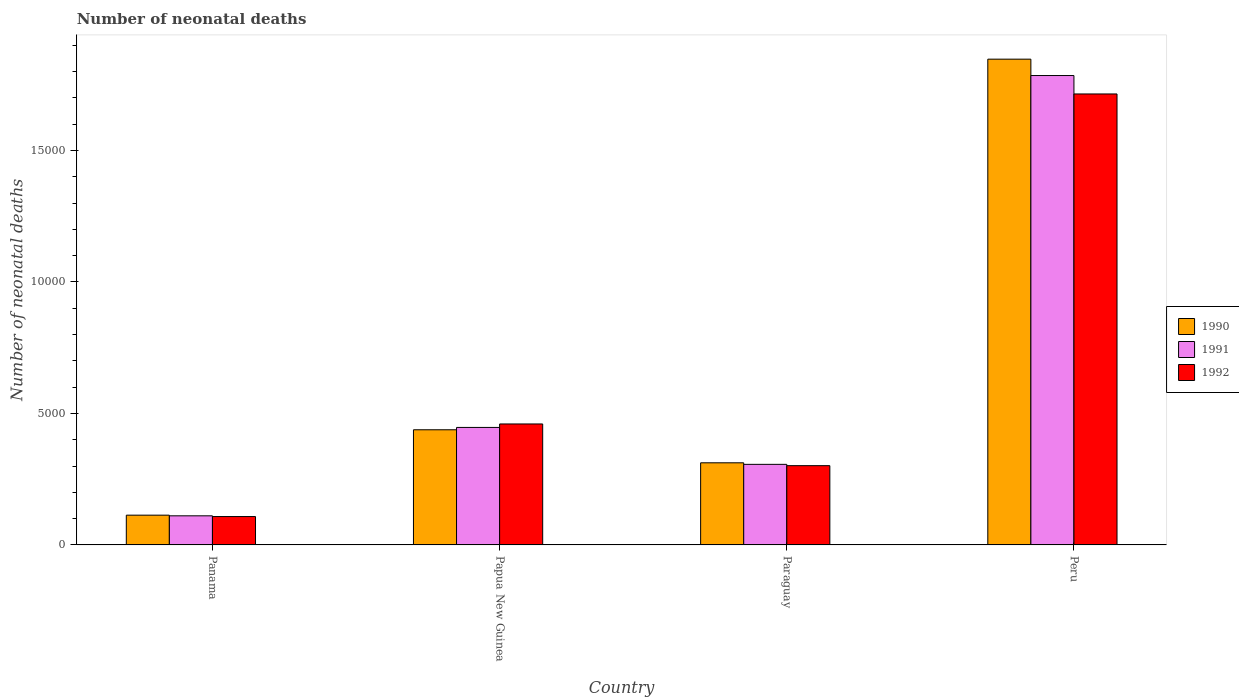How many groups of bars are there?
Keep it short and to the point. 4. Are the number of bars per tick equal to the number of legend labels?
Your answer should be very brief. Yes. How many bars are there on the 4th tick from the left?
Provide a succinct answer. 3. What is the label of the 4th group of bars from the left?
Your answer should be very brief. Peru. In how many cases, is the number of bars for a given country not equal to the number of legend labels?
Keep it short and to the point. 0. What is the number of neonatal deaths in in 1992 in Paraguay?
Ensure brevity in your answer.  3014. Across all countries, what is the maximum number of neonatal deaths in in 1990?
Ensure brevity in your answer.  1.85e+04. Across all countries, what is the minimum number of neonatal deaths in in 1992?
Your answer should be compact. 1079. In which country was the number of neonatal deaths in in 1991 minimum?
Offer a very short reply. Panama. What is the total number of neonatal deaths in in 1992 in the graph?
Provide a short and direct response. 2.58e+04. What is the difference between the number of neonatal deaths in in 1992 in Papua New Guinea and that in Peru?
Your response must be concise. -1.25e+04. What is the difference between the number of neonatal deaths in in 1992 in Papua New Guinea and the number of neonatal deaths in in 1991 in Panama?
Offer a terse response. 3493. What is the average number of neonatal deaths in in 1992 per country?
Offer a terse response. 6460.5. What is the difference between the number of neonatal deaths in of/in 1990 and number of neonatal deaths in of/in 1991 in Panama?
Offer a terse response. 25. What is the ratio of the number of neonatal deaths in in 1991 in Panama to that in Paraguay?
Your response must be concise. 0.36. What is the difference between the highest and the second highest number of neonatal deaths in in 1991?
Your answer should be very brief. -1.48e+04. What is the difference between the highest and the lowest number of neonatal deaths in in 1992?
Give a very brief answer. 1.61e+04. In how many countries, is the number of neonatal deaths in in 1992 greater than the average number of neonatal deaths in in 1992 taken over all countries?
Keep it short and to the point. 1. What does the 2nd bar from the right in Paraguay represents?
Your answer should be very brief. 1991. Is it the case that in every country, the sum of the number of neonatal deaths in in 1991 and number of neonatal deaths in in 1992 is greater than the number of neonatal deaths in in 1990?
Offer a terse response. Yes. Where does the legend appear in the graph?
Provide a succinct answer. Center right. How many legend labels are there?
Your response must be concise. 3. What is the title of the graph?
Make the answer very short. Number of neonatal deaths. What is the label or title of the X-axis?
Your response must be concise. Country. What is the label or title of the Y-axis?
Offer a terse response. Number of neonatal deaths. What is the Number of neonatal deaths in 1990 in Panama?
Make the answer very short. 1132. What is the Number of neonatal deaths of 1991 in Panama?
Provide a succinct answer. 1107. What is the Number of neonatal deaths of 1992 in Panama?
Give a very brief answer. 1079. What is the Number of neonatal deaths in 1990 in Papua New Guinea?
Offer a terse response. 4379. What is the Number of neonatal deaths in 1991 in Papua New Guinea?
Provide a succinct answer. 4468. What is the Number of neonatal deaths of 1992 in Papua New Guinea?
Keep it short and to the point. 4600. What is the Number of neonatal deaths of 1990 in Paraguay?
Keep it short and to the point. 3123. What is the Number of neonatal deaths in 1991 in Paraguay?
Keep it short and to the point. 3064. What is the Number of neonatal deaths of 1992 in Paraguay?
Keep it short and to the point. 3014. What is the Number of neonatal deaths in 1990 in Peru?
Your response must be concise. 1.85e+04. What is the Number of neonatal deaths in 1991 in Peru?
Make the answer very short. 1.78e+04. What is the Number of neonatal deaths in 1992 in Peru?
Provide a succinct answer. 1.71e+04. Across all countries, what is the maximum Number of neonatal deaths in 1990?
Provide a short and direct response. 1.85e+04. Across all countries, what is the maximum Number of neonatal deaths in 1991?
Keep it short and to the point. 1.78e+04. Across all countries, what is the maximum Number of neonatal deaths in 1992?
Provide a short and direct response. 1.71e+04. Across all countries, what is the minimum Number of neonatal deaths of 1990?
Give a very brief answer. 1132. Across all countries, what is the minimum Number of neonatal deaths of 1991?
Your answer should be very brief. 1107. Across all countries, what is the minimum Number of neonatal deaths in 1992?
Give a very brief answer. 1079. What is the total Number of neonatal deaths of 1990 in the graph?
Your response must be concise. 2.71e+04. What is the total Number of neonatal deaths of 1991 in the graph?
Your answer should be very brief. 2.65e+04. What is the total Number of neonatal deaths of 1992 in the graph?
Give a very brief answer. 2.58e+04. What is the difference between the Number of neonatal deaths in 1990 in Panama and that in Papua New Guinea?
Give a very brief answer. -3247. What is the difference between the Number of neonatal deaths in 1991 in Panama and that in Papua New Guinea?
Offer a terse response. -3361. What is the difference between the Number of neonatal deaths in 1992 in Panama and that in Papua New Guinea?
Your response must be concise. -3521. What is the difference between the Number of neonatal deaths in 1990 in Panama and that in Paraguay?
Give a very brief answer. -1991. What is the difference between the Number of neonatal deaths of 1991 in Panama and that in Paraguay?
Provide a short and direct response. -1957. What is the difference between the Number of neonatal deaths in 1992 in Panama and that in Paraguay?
Your answer should be compact. -1935. What is the difference between the Number of neonatal deaths in 1990 in Panama and that in Peru?
Your answer should be very brief. -1.73e+04. What is the difference between the Number of neonatal deaths in 1991 in Panama and that in Peru?
Keep it short and to the point. -1.67e+04. What is the difference between the Number of neonatal deaths of 1992 in Panama and that in Peru?
Make the answer very short. -1.61e+04. What is the difference between the Number of neonatal deaths in 1990 in Papua New Guinea and that in Paraguay?
Keep it short and to the point. 1256. What is the difference between the Number of neonatal deaths of 1991 in Papua New Guinea and that in Paraguay?
Ensure brevity in your answer.  1404. What is the difference between the Number of neonatal deaths in 1992 in Papua New Guinea and that in Paraguay?
Give a very brief answer. 1586. What is the difference between the Number of neonatal deaths of 1990 in Papua New Guinea and that in Peru?
Keep it short and to the point. -1.41e+04. What is the difference between the Number of neonatal deaths of 1991 in Papua New Guinea and that in Peru?
Give a very brief answer. -1.34e+04. What is the difference between the Number of neonatal deaths in 1992 in Papua New Guinea and that in Peru?
Your answer should be compact. -1.25e+04. What is the difference between the Number of neonatal deaths in 1990 in Paraguay and that in Peru?
Offer a terse response. -1.53e+04. What is the difference between the Number of neonatal deaths of 1991 in Paraguay and that in Peru?
Your answer should be compact. -1.48e+04. What is the difference between the Number of neonatal deaths in 1992 in Paraguay and that in Peru?
Your response must be concise. -1.41e+04. What is the difference between the Number of neonatal deaths in 1990 in Panama and the Number of neonatal deaths in 1991 in Papua New Guinea?
Offer a terse response. -3336. What is the difference between the Number of neonatal deaths in 1990 in Panama and the Number of neonatal deaths in 1992 in Papua New Guinea?
Your response must be concise. -3468. What is the difference between the Number of neonatal deaths in 1991 in Panama and the Number of neonatal deaths in 1992 in Papua New Guinea?
Provide a succinct answer. -3493. What is the difference between the Number of neonatal deaths of 1990 in Panama and the Number of neonatal deaths of 1991 in Paraguay?
Your answer should be very brief. -1932. What is the difference between the Number of neonatal deaths of 1990 in Panama and the Number of neonatal deaths of 1992 in Paraguay?
Offer a very short reply. -1882. What is the difference between the Number of neonatal deaths of 1991 in Panama and the Number of neonatal deaths of 1992 in Paraguay?
Make the answer very short. -1907. What is the difference between the Number of neonatal deaths in 1990 in Panama and the Number of neonatal deaths in 1991 in Peru?
Provide a short and direct response. -1.67e+04. What is the difference between the Number of neonatal deaths in 1990 in Panama and the Number of neonatal deaths in 1992 in Peru?
Make the answer very short. -1.60e+04. What is the difference between the Number of neonatal deaths in 1991 in Panama and the Number of neonatal deaths in 1992 in Peru?
Your response must be concise. -1.60e+04. What is the difference between the Number of neonatal deaths in 1990 in Papua New Guinea and the Number of neonatal deaths in 1991 in Paraguay?
Provide a short and direct response. 1315. What is the difference between the Number of neonatal deaths of 1990 in Papua New Guinea and the Number of neonatal deaths of 1992 in Paraguay?
Provide a short and direct response. 1365. What is the difference between the Number of neonatal deaths in 1991 in Papua New Guinea and the Number of neonatal deaths in 1992 in Paraguay?
Ensure brevity in your answer.  1454. What is the difference between the Number of neonatal deaths in 1990 in Papua New Guinea and the Number of neonatal deaths in 1991 in Peru?
Ensure brevity in your answer.  -1.35e+04. What is the difference between the Number of neonatal deaths of 1990 in Papua New Guinea and the Number of neonatal deaths of 1992 in Peru?
Your answer should be compact. -1.28e+04. What is the difference between the Number of neonatal deaths in 1991 in Papua New Guinea and the Number of neonatal deaths in 1992 in Peru?
Provide a succinct answer. -1.27e+04. What is the difference between the Number of neonatal deaths in 1990 in Paraguay and the Number of neonatal deaths in 1991 in Peru?
Your answer should be compact. -1.47e+04. What is the difference between the Number of neonatal deaths of 1990 in Paraguay and the Number of neonatal deaths of 1992 in Peru?
Provide a short and direct response. -1.40e+04. What is the difference between the Number of neonatal deaths in 1991 in Paraguay and the Number of neonatal deaths in 1992 in Peru?
Make the answer very short. -1.41e+04. What is the average Number of neonatal deaths of 1990 per country?
Offer a terse response. 6776.5. What is the average Number of neonatal deaths in 1991 per country?
Provide a short and direct response. 6622. What is the average Number of neonatal deaths of 1992 per country?
Your answer should be compact. 6460.5. What is the difference between the Number of neonatal deaths in 1990 and Number of neonatal deaths in 1991 in Panama?
Provide a succinct answer. 25. What is the difference between the Number of neonatal deaths in 1990 and Number of neonatal deaths in 1992 in Panama?
Your answer should be very brief. 53. What is the difference between the Number of neonatal deaths of 1990 and Number of neonatal deaths of 1991 in Papua New Guinea?
Provide a short and direct response. -89. What is the difference between the Number of neonatal deaths in 1990 and Number of neonatal deaths in 1992 in Papua New Guinea?
Offer a very short reply. -221. What is the difference between the Number of neonatal deaths of 1991 and Number of neonatal deaths of 1992 in Papua New Guinea?
Ensure brevity in your answer.  -132. What is the difference between the Number of neonatal deaths in 1990 and Number of neonatal deaths in 1992 in Paraguay?
Your answer should be compact. 109. What is the difference between the Number of neonatal deaths of 1990 and Number of neonatal deaths of 1991 in Peru?
Provide a short and direct response. 623. What is the difference between the Number of neonatal deaths of 1990 and Number of neonatal deaths of 1992 in Peru?
Give a very brief answer. 1323. What is the difference between the Number of neonatal deaths in 1991 and Number of neonatal deaths in 1992 in Peru?
Make the answer very short. 700. What is the ratio of the Number of neonatal deaths of 1990 in Panama to that in Papua New Guinea?
Give a very brief answer. 0.26. What is the ratio of the Number of neonatal deaths of 1991 in Panama to that in Papua New Guinea?
Offer a terse response. 0.25. What is the ratio of the Number of neonatal deaths in 1992 in Panama to that in Papua New Guinea?
Your answer should be very brief. 0.23. What is the ratio of the Number of neonatal deaths of 1990 in Panama to that in Paraguay?
Give a very brief answer. 0.36. What is the ratio of the Number of neonatal deaths of 1991 in Panama to that in Paraguay?
Offer a very short reply. 0.36. What is the ratio of the Number of neonatal deaths in 1992 in Panama to that in Paraguay?
Keep it short and to the point. 0.36. What is the ratio of the Number of neonatal deaths of 1990 in Panama to that in Peru?
Your answer should be very brief. 0.06. What is the ratio of the Number of neonatal deaths in 1991 in Panama to that in Peru?
Your response must be concise. 0.06. What is the ratio of the Number of neonatal deaths in 1992 in Panama to that in Peru?
Provide a succinct answer. 0.06. What is the ratio of the Number of neonatal deaths in 1990 in Papua New Guinea to that in Paraguay?
Ensure brevity in your answer.  1.4. What is the ratio of the Number of neonatal deaths in 1991 in Papua New Guinea to that in Paraguay?
Keep it short and to the point. 1.46. What is the ratio of the Number of neonatal deaths of 1992 in Papua New Guinea to that in Paraguay?
Provide a short and direct response. 1.53. What is the ratio of the Number of neonatal deaths of 1990 in Papua New Guinea to that in Peru?
Offer a very short reply. 0.24. What is the ratio of the Number of neonatal deaths in 1991 in Papua New Guinea to that in Peru?
Your answer should be compact. 0.25. What is the ratio of the Number of neonatal deaths in 1992 in Papua New Guinea to that in Peru?
Offer a terse response. 0.27. What is the ratio of the Number of neonatal deaths in 1990 in Paraguay to that in Peru?
Give a very brief answer. 0.17. What is the ratio of the Number of neonatal deaths in 1991 in Paraguay to that in Peru?
Provide a short and direct response. 0.17. What is the ratio of the Number of neonatal deaths of 1992 in Paraguay to that in Peru?
Keep it short and to the point. 0.18. What is the difference between the highest and the second highest Number of neonatal deaths in 1990?
Offer a terse response. 1.41e+04. What is the difference between the highest and the second highest Number of neonatal deaths in 1991?
Offer a terse response. 1.34e+04. What is the difference between the highest and the second highest Number of neonatal deaths in 1992?
Keep it short and to the point. 1.25e+04. What is the difference between the highest and the lowest Number of neonatal deaths of 1990?
Offer a terse response. 1.73e+04. What is the difference between the highest and the lowest Number of neonatal deaths of 1991?
Your answer should be compact. 1.67e+04. What is the difference between the highest and the lowest Number of neonatal deaths of 1992?
Ensure brevity in your answer.  1.61e+04. 